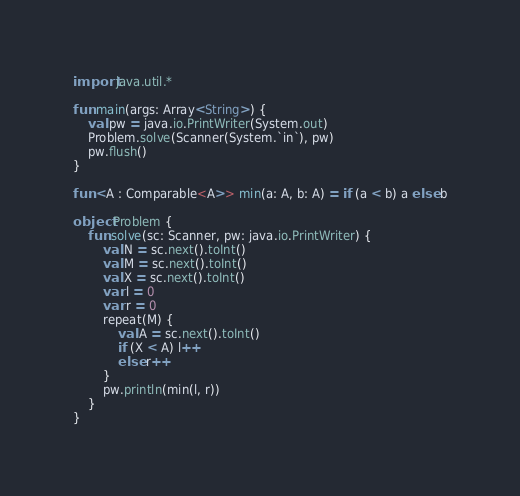Convert code to text. <code><loc_0><loc_0><loc_500><loc_500><_Kotlin_>import java.util.*

fun main(args: Array<String>) {
    val pw = java.io.PrintWriter(System.out)
    Problem.solve(Scanner(System.`in`), pw)
    pw.flush()
}

fun <A : Comparable<A>> min(a: A, b: A) = if (a < b) a else b

object Problem {
    fun solve(sc: Scanner, pw: java.io.PrintWriter) {
        val N = sc.next().toInt()
        val M = sc.next().toInt()
        val X = sc.next().toInt()
        var l = 0
        var r = 0
        repeat(M) {
            val A = sc.next().toInt()
            if (X < A) l++
            else r++
        }
        pw.println(min(l, r))
    }
}
</code> 